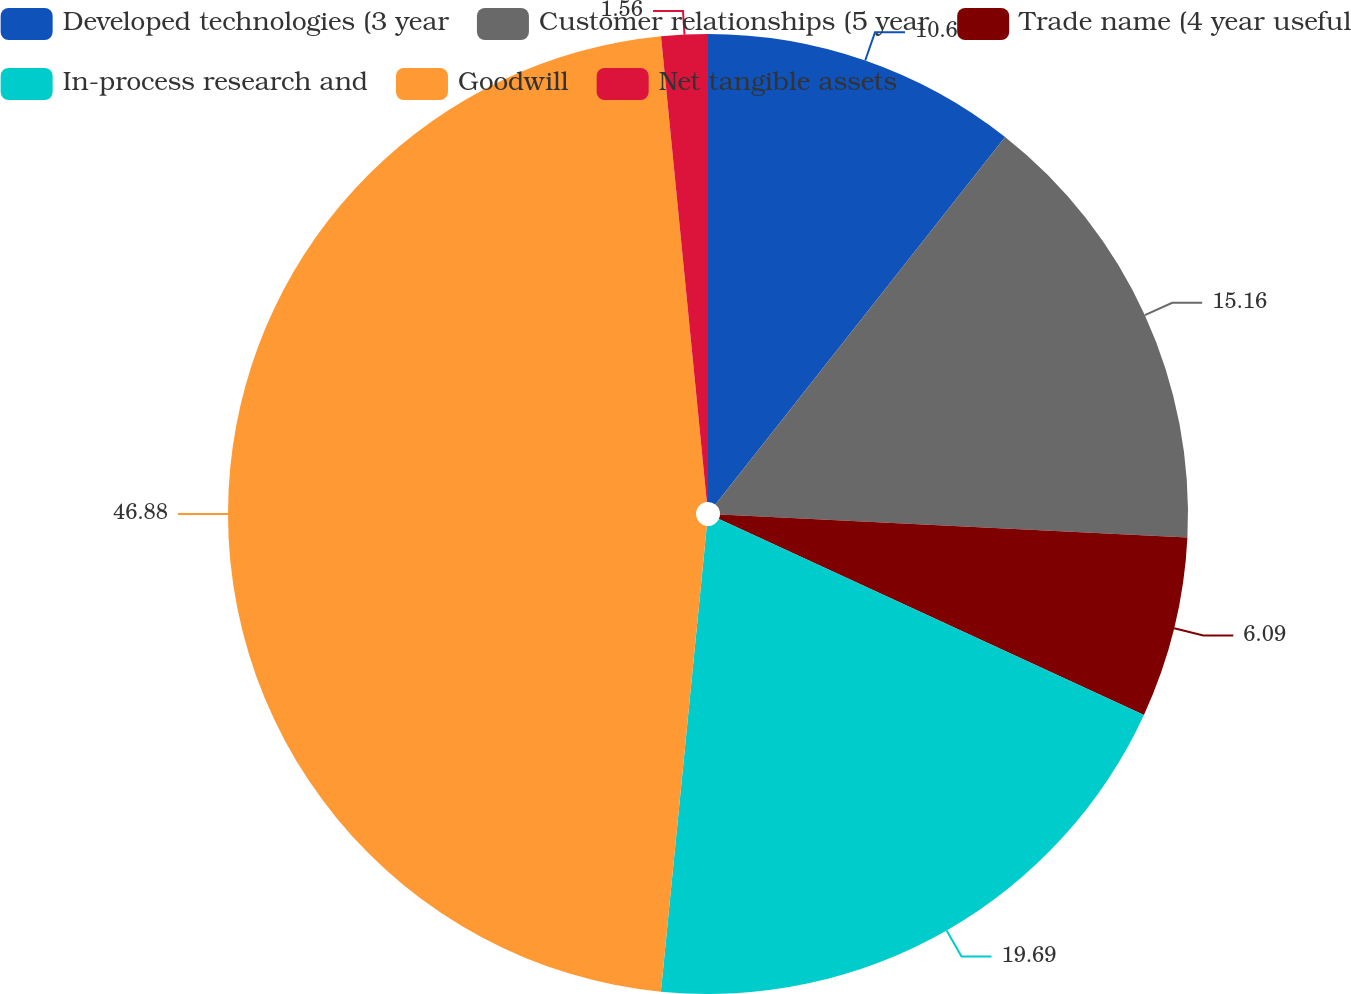<chart> <loc_0><loc_0><loc_500><loc_500><pie_chart><fcel>Developed technologies (3 year<fcel>Customer relationships (5 year<fcel>Trade name (4 year useful<fcel>In-process research and<fcel>Goodwill<fcel>Net tangible assets<nl><fcel>10.62%<fcel>15.16%<fcel>6.09%<fcel>19.69%<fcel>46.87%<fcel>1.56%<nl></chart> 